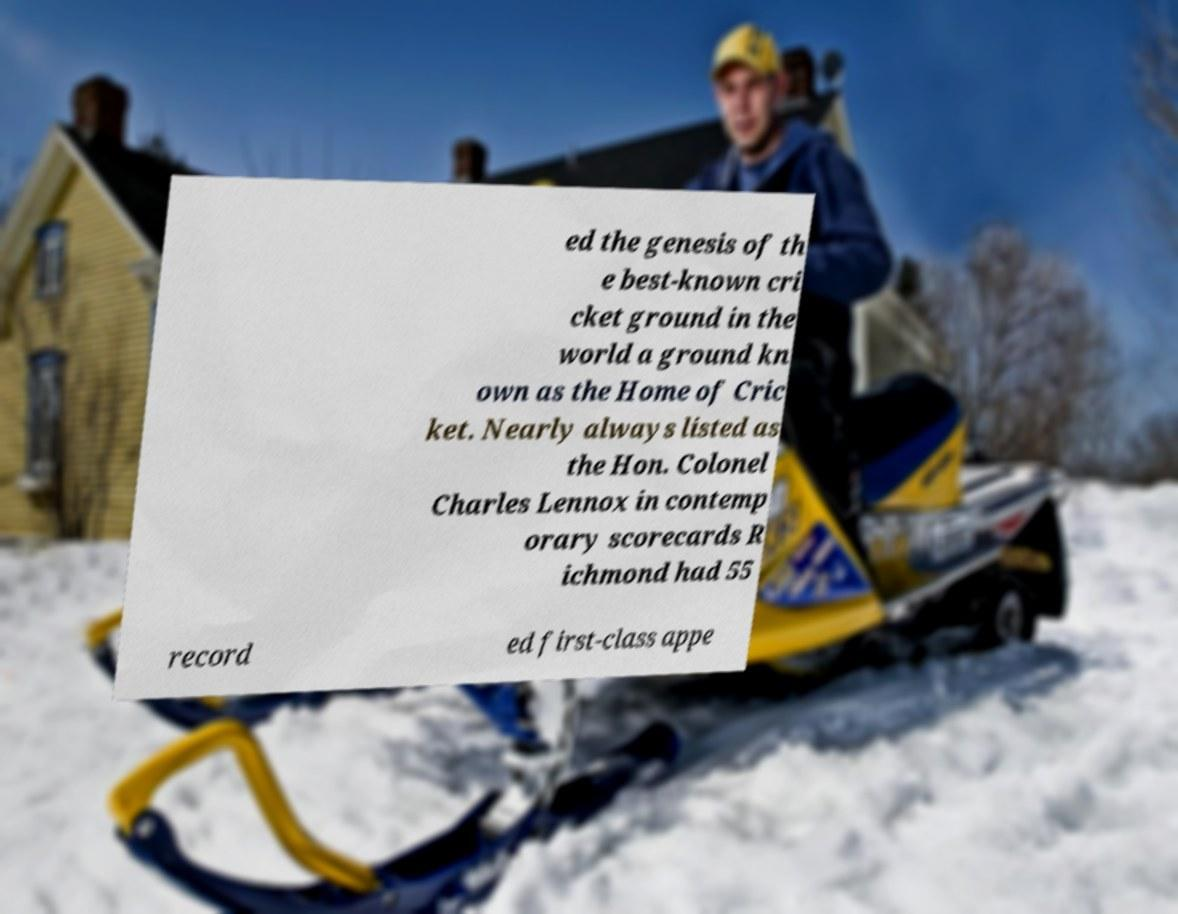For documentation purposes, I need the text within this image transcribed. Could you provide that? ed the genesis of th e best-known cri cket ground in the world a ground kn own as the Home of Cric ket. Nearly always listed as the Hon. Colonel Charles Lennox in contemp orary scorecards R ichmond had 55 record ed first-class appe 